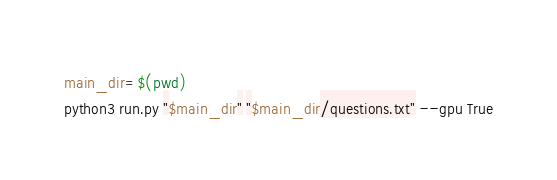<code> <loc_0><loc_0><loc_500><loc_500><_Bash_>
main_dir=$(pwd)
python3 run.py "$main_dir" "$main_dir/questions.txt" --gpu True</code> 